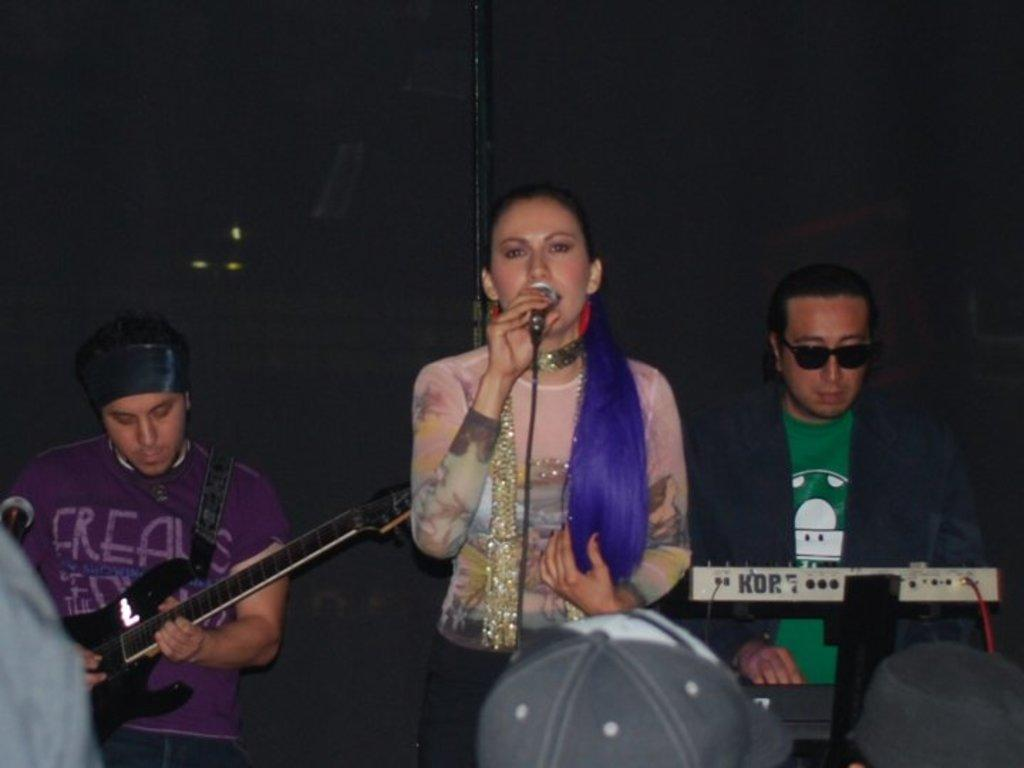Who or what is present in the image? There are people in the image. What are the people holding in the image? The people are holding guitars and microphones. What type of instrument are the people playing in the image? The people are playing a Casio instrument. What type of gold jewelry can be seen on the people in the image? There is no gold jewelry visible on the people in the image. What type of music is being played by the people in the image? The specific type of music being played cannot be determined from the image alone. Is there a rail or train visible in the image? There is no rail or train present in the image. 